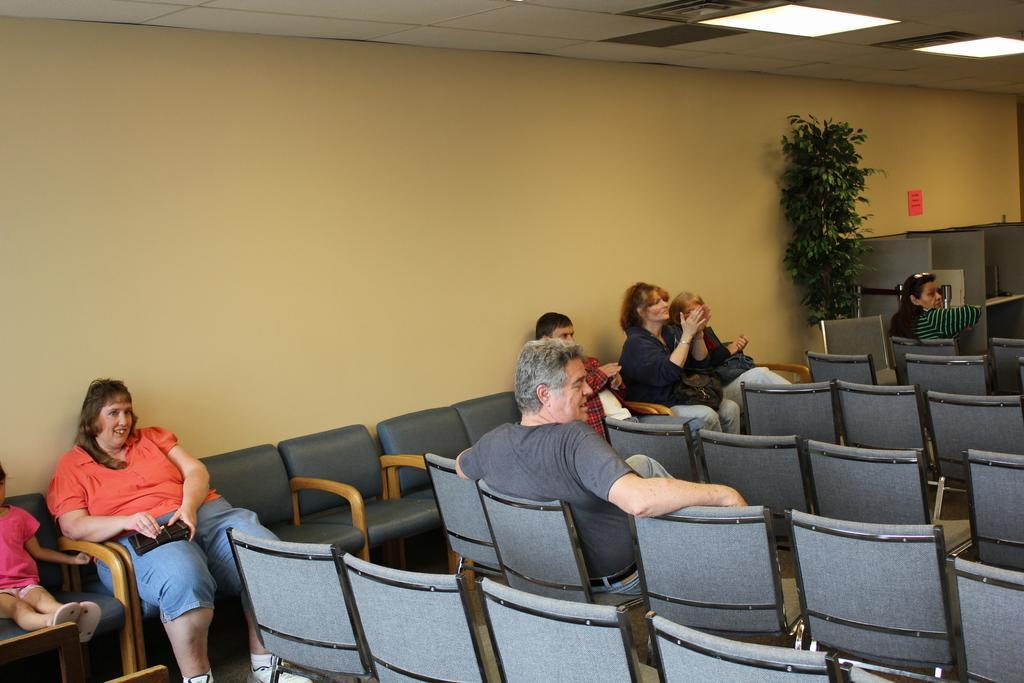Please provide a concise description of this image. This is the picture of a room where we have a lot of chairs and seven people sitting on the chairs and also there is a plant and a shelf in the room. 